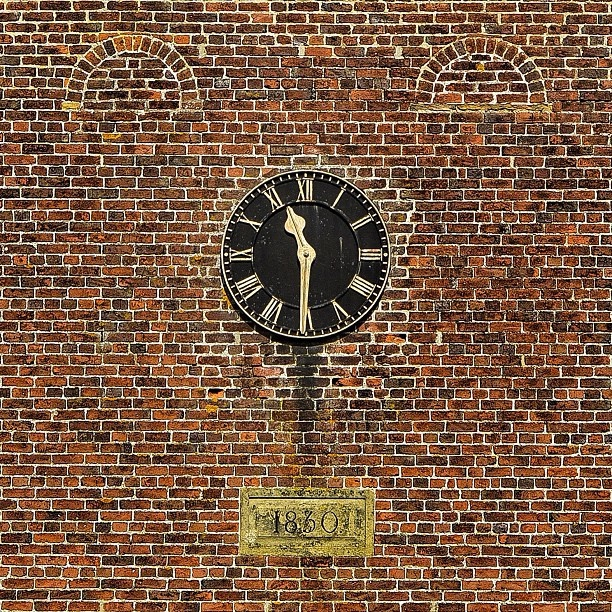Describe the objects in this image and their specific colors. I can see a clock in lightyellow, black, beige, and gray tones in this image. 